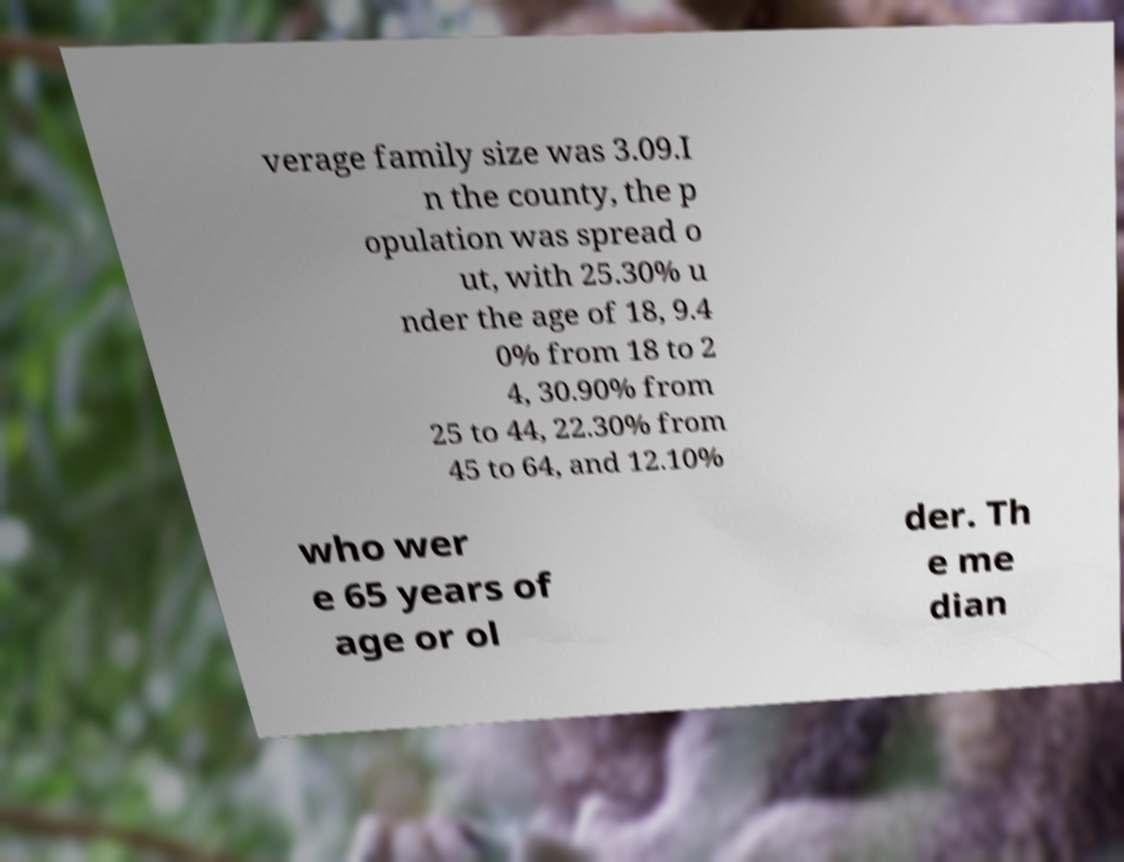Could you assist in decoding the text presented in this image and type it out clearly? verage family size was 3.09.I n the county, the p opulation was spread o ut, with 25.30% u nder the age of 18, 9.4 0% from 18 to 2 4, 30.90% from 25 to 44, 22.30% from 45 to 64, and 12.10% who wer e 65 years of age or ol der. Th e me dian 